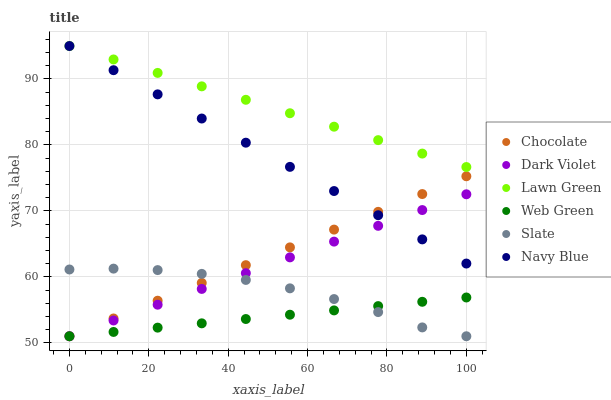Does Web Green have the minimum area under the curve?
Answer yes or no. Yes. Does Lawn Green have the maximum area under the curve?
Answer yes or no. Yes. Does Navy Blue have the minimum area under the curve?
Answer yes or no. No. Does Navy Blue have the maximum area under the curve?
Answer yes or no. No. Is Dark Violet the smoothest?
Answer yes or no. Yes. Is Slate the roughest?
Answer yes or no. Yes. Is Navy Blue the smoothest?
Answer yes or no. No. Is Navy Blue the roughest?
Answer yes or no. No. Does Slate have the lowest value?
Answer yes or no. Yes. Does Navy Blue have the lowest value?
Answer yes or no. No. Does Navy Blue have the highest value?
Answer yes or no. Yes. Does Slate have the highest value?
Answer yes or no. No. Is Web Green less than Lawn Green?
Answer yes or no. Yes. Is Navy Blue greater than Web Green?
Answer yes or no. Yes. Does Navy Blue intersect Lawn Green?
Answer yes or no. Yes. Is Navy Blue less than Lawn Green?
Answer yes or no. No. Is Navy Blue greater than Lawn Green?
Answer yes or no. No. Does Web Green intersect Lawn Green?
Answer yes or no. No. 